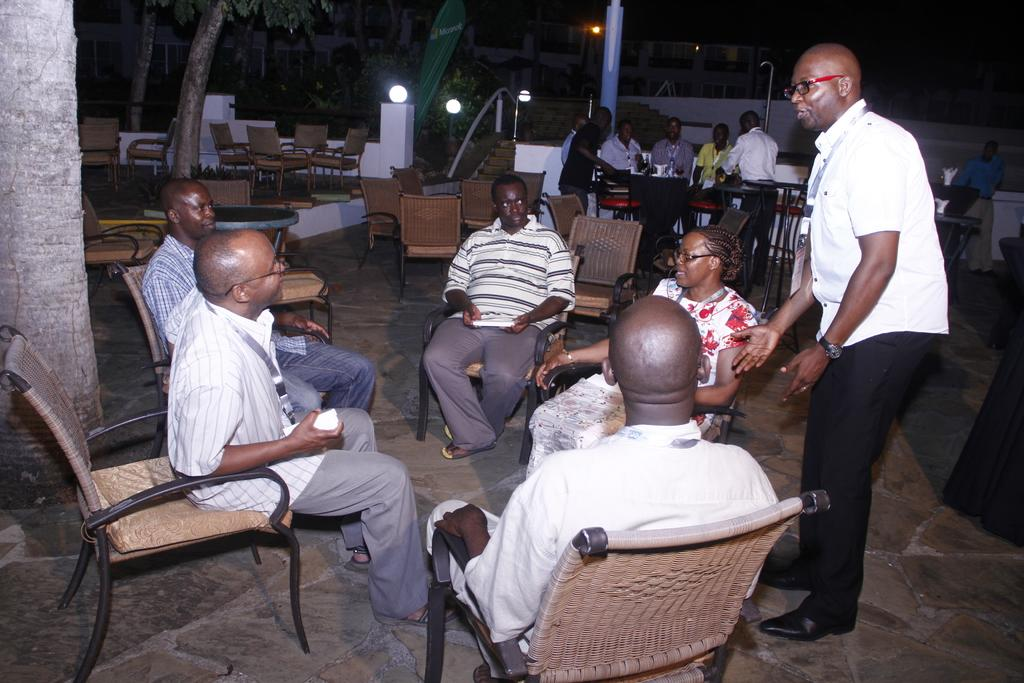What are the people in the image doing? The persons in the image are sitting on chairs. What is the surface beneath the people and the standing man? There is a floor visible in the image. What can be seen illuminating the area in the image? There are lights in the image. What is the man in the image doing? There is a man standing on the floor in the image. What type of reward is being given to the person sitting on the chair in the image? There is no reward being given in the image; the persons are simply sitting on chairs. 